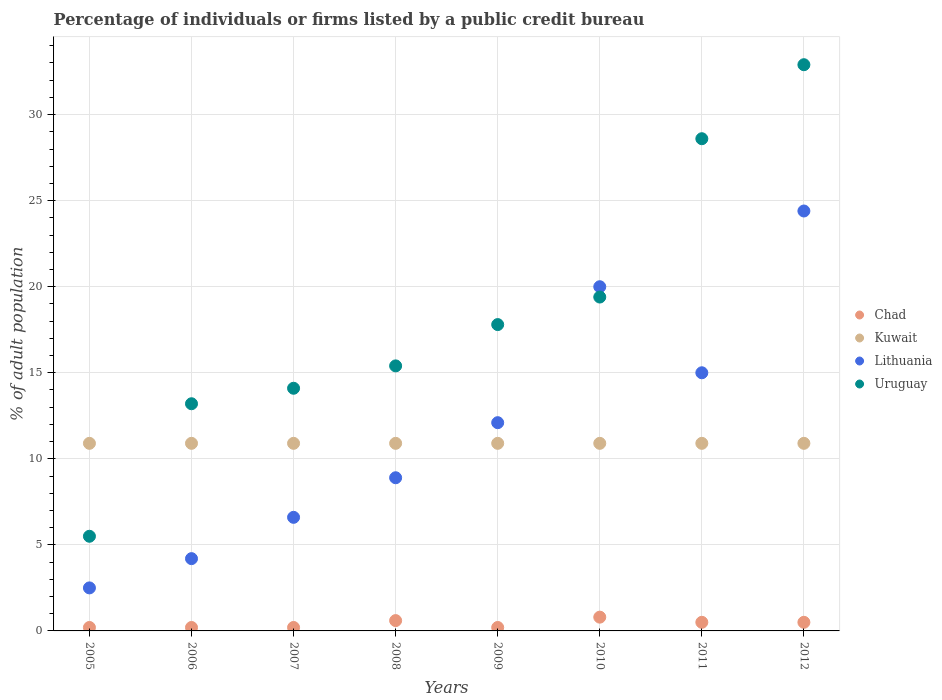How many different coloured dotlines are there?
Keep it short and to the point. 4. Is the number of dotlines equal to the number of legend labels?
Provide a succinct answer. Yes. What is the percentage of population listed by a public credit bureau in Chad in 2011?
Your answer should be compact. 0.5. Across all years, what is the maximum percentage of population listed by a public credit bureau in Kuwait?
Offer a very short reply. 10.9. Across all years, what is the minimum percentage of population listed by a public credit bureau in Lithuania?
Your response must be concise. 2.5. In which year was the percentage of population listed by a public credit bureau in Uruguay maximum?
Keep it short and to the point. 2012. What is the difference between the percentage of population listed by a public credit bureau in Kuwait in 2011 and the percentage of population listed by a public credit bureau in Uruguay in 2008?
Keep it short and to the point. -4.5. What is the average percentage of population listed by a public credit bureau in Chad per year?
Make the answer very short. 0.4. In the year 2007, what is the difference between the percentage of population listed by a public credit bureau in Kuwait and percentage of population listed by a public credit bureau in Lithuania?
Offer a very short reply. 4.3. What is the ratio of the percentage of population listed by a public credit bureau in Uruguay in 2006 to that in 2012?
Offer a terse response. 0.4. What is the difference between the highest and the lowest percentage of population listed by a public credit bureau in Kuwait?
Your answer should be very brief. 0. In how many years, is the percentage of population listed by a public credit bureau in Chad greater than the average percentage of population listed by a public credit bureau in Chad taken over all years?
Offer a terse response. 4. Is it the case that in every year, the sum of the percentage of population listed by a public credit bureau in Uruguay and percentage of population listed by a public credit bureau in Chad  is greater than the percentage of population listed by a public credit bureau in Kuwait?
Your response must be concise. No. Does the percentage of population listed by a public credit bureau in Lithuania monotonically increase over the years?
Your answer should be compact. No. Is the percentage of population listed by a public credit bureau in Kuwait strictly greater than the percentage of population listed by a public credit bureau in Uruguay over the years?
Offer a terse response. No. How many dotlines are there?
Your response must be concise. 4. How many years are there in the graph?
Ensure brevity in your answer.  8. What is the difference between two consecutive major ticks on the Y-axis?
Keep it short and to the point. 5. Are the values on the major ticks of Y-axis written in scientific E-notation?
Your answer should be compact. No. Does the graph contain any zero values?
Offer a terse response. No. What is the title of the graph?
Give a very brief answer. Percentage of individuals or firms listed by a public credit bureau. What is the label or title of the X-axis?
Make the answer very short. Years. What is the label or title of the Y-axis?
Offer a terse response. % of adult population. What is the % of adult population in Chad in 2005?
Ensure brevity in your answer.  0.2. What is the % of adult population of Kuwait in 2005?
Offer a terse response. 10.9. What is the % of adult population in Uruguay in 2005?
Your answer should be very brief. 5.5. What is the % of adult population in Lithuania in 2006?
Offer a terse response. 4.2. What is the % of adult population of Uruguay in 2006?
Offer a terse response. 13.2. What is the % of adult population in Lithuania in 2007?
Keep it short and to the point. 6.6. What is the % of adult population of Uruguay in 2007?
Offer a terse response. 14.1. What is the % of adult population in Chad in 2008?
Your response must be concise. 0.6. What is the % of adult population in Lithuania in 2008?
Make the answer very short. 8.9. What is the % of adult population in Chad in 2009?
Provide a short and direct response. 0.2. What is the % of adult population of Kuwait in 2009?
Offer a very short reply. 10.9. What is the % of adult population of Chad in 2010?
Your response must be concise. 0.8. What is the % of adult population in Lithuania in 2010?
Keep it short and to the point. 20. What is the % of adult population in Chad in 2011?
Your response must be concise. 0.5. What is the % of adult population of Lithuania in 2011?
Keep it short and to the point. 15. What is the % of adult population of Uruguay in 2011?
Your response must be concise. 28.6. What is the % of adult population in Kuwait in 2012?
Provide a short and direct response. 10.9. What is the % of adult population of Lithuania in 2012?
Provide a succinct answer. 24.4. What is the % of adult population in Uruguay in 2012?
Your response must be concise. 32.9. Across all years, what is the maximum % of adult population in Chad?
Keep it short and to the point. 0.8. Across all years, what is the maximum % of adult population of Lithuania?
Your answer should be compact. 24.4. Across all years, what is the maximum % of adult population of Uruguay?
Your response must be concise. 32.9. Across all years, what is the minimum % of adult population of Chad?
Give a very brief answer. 0.2. Across all years, what is the minimum % of adult population in Kuwait?
Provide a succinct answer. 10.9. Across all years, what is the minimum % of adult population in Uruguay?
Your response must be concise. 5.5. What is the total % of adult population in Chad in the graph?
Give a very brief answer. 3.2. What is the total % of adult population of Kuwait in the graph?
Keep it short and to the point. 87.2. What is the total % of adult population in Lithuania in the graph?
Provide a succinct answer. 93.7. What is the total % of adult population in Uruguay in the graph?
Provide a succinct answer. 146.9. What is the difference between the % of adult population of Lithuania in 2005 and that in 2006?
Your response must be concise. -1.7. What is the difference between the % of adult population of Uruguay in 2005 and that in 2006?
Ensure brevity in your answer.  -7.7. What is the difference between the % of adult population of Chad in 2005 and that in 2007?
Your response must be concise. 0. What is the difference between the % of adult population in Lithuania in 2005 and that in 2007?
Your answer should be compact. -4.1. What is the difference between the % of adult population of Uruguay in 2005 and that in 2007?
Offer a terse response. -8.6. What is the difference between the % of adult population of Lithuania in 2005 and that in 2009?
Provide a succinct answer. -9.6. What is the difference between the % of adult population of Chad in 2005 and that in 2010?
Provide a succinct answer. -0.6. What is the difference between the % of adult population in Lithuania in 2005 and that in 2010?
Ensure brevity in your answer.  -17.5. What is the difference between the % of adult population in Uruguay in 2005 and that in 2010?
Offer a terse response. -13.9. What is the difference between the % of adult population of Chad in 2005 and that in 2011?
Provide a short and direct response. -0.3. What is the difference between the % of adult population of Lithuania in 2005 and that in 2011?
Provide a short and direct response. -12.5. What is the difference between the % of adult population in Uruguay in 2005 and that in 2011?
Your answer should be compact. -23.1. What is the difference between the % of adult population in Chad in 2005 and that in 2012?
Your response must be concise. -0.3. What is the difference between the % of adult population of Lithuania in 2005 and that in 2012?
Your answer should be very brief. -21.9. What is the difference between the % of adult population of Uruguay in 2005 and that in 2012?
Offer a very short reply. -27.4. What is the difference between the % of adult population in Lithuania in 2006 and that in 2007?
Make the answer very short. -2.4. What is the difference between the % of adult population of Lithuania in 2006 and that in 2008?
Your answer should be compact. -4.7. What is the difference between the % of adult population in Chad in 2006 and that in 2009?
Ensure brevity in your answer.  0. What is the difference between the % of adult population in Lithuania in 2006 and that in 2009?
Offer a terse response. -7.9. What is the difference between the % of adult population in Uruguay in 2006 and that in 2009?
Ensure brevity in your answer.  -4.6. What is the difference between the % of adult population in Chad in 2006 and that in 2010?
Your answer should be very brief. -0.6. What is the difference between the % of adult population in Lithuania in 2006 and that in 2010?
Offer a terse response. -15.8. What is the difference between the % of adult population of Kuwait in 2006 and that in 2011?
Offer a terse response. 0. What is the difference between the % of adult population of Uruguay in 2006 and that in 2011?
Provide a succinct answer. -15.4. What is the difference between the % of adult population in Chad in 2006 and that in 2012?
Ensure brevity in your answer.  -0.3. What is the difference between the % of adult population of Kuwait in 2006 and that in 2012?
Your response must be concise. 0. What is the difference between the % of adult population of Lithuania in 2006 and that in 2012?
Ensure brevity in your answer.  -20.2. What is the difference between the % of adult population in Uruguay in 2006 and that in 2012?
Provide a succinct answer. -19.7. What is the difference between the % of adult population of Kuwait in 2007 and that in 2008?
Offer a terse response. 0. What is the difference between the % of adult population of Chad in 2007 and that in 2009?
Give a very brief answer. 0. What is the difference between the % of adult population of Chad in 2007 and that in 2010?
Your answer should be compact. -0.6. What is the difference between the % of adult population of Kuwait in 2007 and that in 2010?
Make the answer very short. 0. What is the difference between the % of adult population of Uruguay in 2007 and that in 2010?
Keep it short and to the point. -5.3. What is the difference between the % of adult population of Uruguay in 2007 and that in 2011?
Offer a very short reply. -14.5. What is the difference between the % of adult population in Chad in 2007 and that in 2012?
Your answer should be compact. -0.3. What is the difference between the % of adult population in Kuwait in 2007 and that in 2012?
Provide a succinct answer. 0. What is the difference between the % of adult population of Lithuania in 2007 and that in 2012?
Keep it short and to the point. -17.8. What is the difference between the % of adult population in Uruguay in 2007 and that in 2012?
Your answer should be very brief. -18.8. What is the difference between the % of adult population of Lithuania in 2008 and that in 2009?
Give a very brief answer. -3.2. What is the difference between the % of adult population of Uruguay in 2008 and that in 2009?
Offer a terse response. -2.4. What is the difference between the % of adult population in Chad in 2008 and that in 2010?
Provide a succinct answer. -0.2. What is the difference between the % of adult population in Lithuania in 2008 and that in 2010?
Offer a very short reply. -11.1. What is the difference between the % of adult population in Uruguay in 2008 and that in 2010?
Make the answer very short. -4. What is the difference between the % of adult population in Chad in 2008 and that in 2011?
Your answer should be very brief. 0.1. What is the difference between the % of adult population of Lithuania in 2008 and that in 2011?
Your answer should be compact. -6.1. What is the difference between the % of adult population in Kuwait in 2008 and that in 2012?
Ensure brevity in your answer.  0. What is the difference between the % of adult population in Lithuania in 2008 and that in 2012?
Make the answer very short. -15.5. What is the difference between the % of adult population of Uruguay in 2008 and that in 2012?
Provide a succinct answer. -17.5. What is the difference between the % of adult population in Chad in 2009 and that in 2010?
Your answer should be very brief. -0.6. What is the difference between the % of adult population in Chad in 2009 and that in 2011?
Ensure brevity in your answer.  -0.3. What is the difference between the % of adult population of Kuwait in 2009 and that in 2011?
Offer a terse response. 0. What is the difference between the % of adult population of Uruguay in 2009 and that in 2011?
Your response must be concise. -10.8. What is the difference between the % of adult population in Chad in 2009 and that in 2012?
Ensure brevity in your answer.  -0.3. What is the difference between the % of adult population of Uruguay in 2009 and that in 2012?
Provide a succinct answer. -15.1. What is the difference between the % of adult population of Kuwait in 2010 and that in 2011?
Your answer should be very brief. 0. What is the difference between the % of adult population of Lithuania in 2010 and that in 2012?
Your answer should be compact. -4.4. What is the difference between the % of adult population in Chad in 2011 and that in 2012?
Your answer should be compact. 0. What is the difference between the % of adult population in Uruguay in 2011 and that in 2012?
Your response must be concise. -4.3. What is the difference between the % of adult population in Chad in 2005 and the % of adult population in Lithuania in 2006?
Keep it short and to the point. -4. What is the difference between the % of adult population in Chad in 2005 and the % of adult population in Uruguay in 2006?
Keep it short and to the point. -13. What is the difference between the % of adult population of Kuwait in 2005 and the % of adult population of Lithuania in 2006?
Provide a succinct answer. 6.7. What is the difference between the % of adult population in Chad in 2005 and the % of adult population in Kuwait in 2007?
Offer a very short reply. -10.7. What is the difference between the % of adult population in Chad in 2005 and the % of adult population in Uruguay in 2007?
Ensure brevity in your answer.  -13.9. What is the difference between the % of adult population of Kuwait in 2005 and the % of adult population of Lithuania in 2007?
Your response must be concise. 4.3. What is the difference between the % of adult population in Lithuania in 2005 and the % of adult population in Uruguay in 2007?
Offer a very short reply. -11.6. What is the difference between the % of adult population in Chad in 2005 and the % of adult population in Kuwait in 2008?
Ensure brevity in your answer.  -10.7. What is the difference between the % of adult population in Chad in 2005 and the % of adult population in Lithuania in 2008?
Your response must be concise. -8.7. What is the difference between the % of adult population in Chad in 2005 and the % of adult population in Uruguay in 2008?
Keep it short and to the point. -15.2. What is the difference between the % of adult population in Kuwait in 2005 and the % of adult population in Lithuania in 2008?
Offer a very short reply. 2. What is the difference between the % of adult population in Chad in 2005 and the % of adult population in Kuwait in 2009?
Your response must be concise. -10.7. What is the difference between the % of adult population in Chad in 2005 and the % of adult population in Uruguay in 2009?
Make the answer very short. -17.6. What is the difference between the % of adult population of Kuwait in 2005 and the % of adult population of Lithuania in 2009?
Ensure brevity in your answer.  -1.2. What is the difference between the % of adult population of Kuwait in 2005 and the % of adult population of Uruguay in 2009?
Your answer should be very brief. -6.9. What is the difference between the % of adult population in Lithuania in 2005 and the % of adult population in Uruguay in 2009?
Keep it short and to the point. -15.3. What is the difference between the % of adult population in Chad in 2005 and the % of adult population in Kuwait in 2010?
Your answer should be compact. -10.7. What is the difference between the % of adult population in Chad in 2005 and the % of adult population in Lithuania in 2010?
Provide a short and direct response. -19.8. What is the difference between the % of adult population in Chad in 2005 and the % of adult population in Uruguay in 2010?
Keep it short and to the point. -19.2. What is the difference between the % of adult population in Kuwait in 2005 and the % of adult population in Uruguay in 2010?
Make the answer very short. -8.5. What is the difference between the % of adult population of Lithuania in 2005 and the % of adult population of Uruguay in 2010?
Your answer should be very brief. -16.9. What is the difference between the % of adult population of Chad in 2005 and the % of adult population of Kuwait in 2011?
Offer a terse response. -10.7. What is the difference between the % of adult population in Chad in 2005 and the % of adult population in Lithuania in 2011?
Keep it short and to the point. -14.8. What is the difference between the % of adult population in Chad in 2005 and the % of adult population in Uruguay in 2011?
Your answer should be compact. -28.4. What is the difference between the % of adult population of Kuwait in 2005 and the % of adult population of Lithuania in 2011?
Ensure brevity in your answer.  -4.1. What is the difference between the % of adult population of Kuwait in 2005 and the % of adult population of Uruguay in 2011?
Your answer should be compact. -17.7. What is the difference between the % of adult population of Lithuania in 2005 and the % of adult population of Uruguay in 2011?
Your response must be concise. -26.1. What is the difference between the % of adult population in Chad in 2005 and the % of adult population in Lithuania in 2012?
Your answer should be very brief. -24.2. What is the difference between the % of adult population in Chad in 2005 and the % of adult population in Uruguay in 2012?
Keep it short and to the point. -32.7. What is the difference between the % of adult population of Lithuania in 2005 and the % of adult population of Uruguay in 2012?
Give a very brief answer. -30.4. What is the difference between the % of adult population in Chad in 2006 and the % of adult population in Lithuania in 2007?
Your response must be concise. -6.4. What is the difference between the % of adult population of Chad in 2006 and the % of adult population of Uruguay in 2007?
Offer a terse response. -13.9. What is the difference between the % of adult population in Kuwait in 2006 and the % of adult population in Uruguay in 2007?
Make the answer very short. -3.2. What is the difference between the % of adult population of Lithuania in 2006 and the % of adult population of Uruguay in 2007?
Offer a very short reply. -9.9. What is the difference between the % of adult population in Chad in 2006 and the % of adult population in Kuwait in 2008?
Give a very brief answer. -10.7. What is the difference between the % of adult population of Chad in 2006 and the % of adult population of Uruguay in 2008?
Provide a short and direct response. -15.2. What is the difference between the % of adult population of Kuwait in 2006 and the % of adult population of Lithuania in 2008?
Provide a succinct answer. 2. What is the difference between the % of adult population in Chad in 2006 and the % of adult population in Lithuania in 2009?
Provide a short and direct response. -11.9. What is the difference between the % of adult population in Chad in 2006 and the % of adult population in Uruguay in 2009?
Make the answer very short. -17.6. What is the difference between the % of adult population in Lithuania in 2006 and the % of adult population in Uruguay in 2009?
Your response must be concise. -13.6. What is the difference between the % of adult population of Chad in 2006 and the % of adult population of Kuwait in 2010?
Your answer should be compact. -10.7. What is the difference between the % of adult population of Chad in 2006 and the % of adult population of Lithuania in 2010?
Make the answer very short. -19.8. What is the difference between the % of adult population of Chad in 2006 and the % of adult population of Uruguay in 2010?
Ensure brevity in your answer.  -19.2. What is the difference between the % of adult population in Lithuania in 2006 and the % of adult population in Uruguay in 2010?
Ensure brevity in your answer.  -15.2. What is the difference between the % of adult population of Chad in 2006 and the % of adult population of Lithuania in 2011?
Offer a very short reply. -14.8. What is the difference between the % of adult population in Chad in 2006 and the % of adult population in Uruguay in 2011?
Offer a terse response. -28.4. What is the difference between the % of adult population of Kuwait in 2006 and the % of adult population of Uruguay in 2011?
Provide a short and direct response. -17.7. What is the difference between the % of adult population in Lithuania in 2006 and the % of adult population in Uruguay in 2011?
Give a very brief answer. -24.4. What is the difference between the % of adult population in Chad in 2006 and the % of adult population in Lithuania in 2012?
Offer a very short reply. -24.2. What is the difference between the % of adult population of Chad in 2006 and the % of adult population of Uruguay in 2012?
Your response must be concise. -32.7. What is the difference between the % of adult population of Kuwait in 2006 and the % of adult population of Lithuania in 2012?
Ensure brevity in your answer.  -13.5. What is the difference between the % of adult population in Kuwait in 2006 and the % of adult population in Uruguay in 2012?
Your answer should be compact. -22. What is the difference between the % of adult population of Lithuania in 2006 and the % of adult population of Uruguay in 2012?
Provide a succinct answer. -28.7. What is the difference between the % of adult population of Chad in 2007 and the % of adult population of Kuwait in 2008?
Your answer should be very brief. -10.7. What is the difference between the % of adult population of Chad in 2007 and the % of adult population of Uruguay in 2008?
Your response must be concise. -15.2. What is the difference between the % of adult population of Lithuania in 2007 and the % of adult population of Uruguay in 2008?
Provide a succinct answer. -8.8. What is the difference between the % of adult population in Chad in 2007 and the % of adult population in Kuwait in 2009?
Provide a short and direct response. -10.7. What is the difference between the % of adult population in Chad in 2007 and the % of adult population in Lithuania in 2009?
Your response must be concise. -11.9. What is the difference between the % of adult population of Chad in 2007 and the % of adult population of Uruguay in 2009?
Your answer should be very brief. -17.6. What is the difference between the % of adult population of Kuwait in 2007 and the % of adult population of Lithuania in 2009?
Give a very brief answer. -1.2. What is the difference between the % of adult population in Kuwait in 2007 and the % of adult population in Uruguay in 2009?
Your answer should be compact. -6.9. What is the difference between the % of adult population in Lithuania in 2007 and the % of adult population in Uruguay in 2009?
Offer a terse response. -11.2. What is the difference between the % of adult population of Chad in 2007 and the % of adult population of Lithuania in 2010?
Your answer should be compact. -19.8. What is the difference between the % of adult population of Chad in 2007 and the % of adult population of Uruguay in 2010?
Give a very brief answer. -19.2. What is the difference between the % of adult population of Kuwait in 2007 and the % of adult population of Lithuania in 2010?
Provide a succinct answer. -9.1. What is the difference between the % of adult population in Chad in 2007 and the % of adult population in Lithuania in 2011?
Keep it short and to the point. -14.8. What is the difference between the % of adult population of Chad in 2007 and the % of adult population of Uruguay in 2011?
Offer a very short reply. -28.4. What is the difference between the % of adult population in Kuwait in 2007 and the % of adult population in Uruguay in 2011?
Offer a very short reply. -17.7. What is the difference between the % of adult population in Chad in 2007 and the % of adult population in Lithuania in 2012?
Offer a terse response. -24.2. What is the difference between the % of adult population in Chad in 2007 and the % of adult population in Uruguay in 2012?
Offer a very short reply. -32.7. What is the difference between the % of adult population of Kuwait in 2007 and the % of adult population of Uruguay in 2012?
Your response must be concise. -22. What is the difference between the % of adult population of Lithuania in 2007 and the % of adult population of Uruguay in 2012?
Ensure brevity in your answer.  -26.3. What is the difference between the % of adult population in Chad in 2008 and the % of adult population in Kuwait in 2009?
Your response must be concise. -10.3. What is the difference between the % of adult population in Chad in 2008 and the % of adult population in Uruguay in 2009?
Offer a terse response. -17.2. What is the difference between the % of adult population of Kuwait in 2008 and the % of adult population of Uruguay in 2009?
Provide a short and direct response. -6.9. What is the difference between the % of adult population in Lithuania in 2008 and the % of adult population in Uruguay in 2009?
Offer a very short reply. -8.9. What is the difference between the % of adult population of Chad in 2008 and the % of adult population of Kuwait in 2010?
Provide a succinct answer. -10.3. What is the difference between the % of adult population of Chad in 2008 and the % of adult population of Lithuania in 2010?
Provide a succinct answer. -19.4. What is the difference between the % of adult population in Chad in 2008 and the % of adult population in Uruguay in 2010?
Make the answer very short. -18.8. What is the difference between the % of adult population of Kuwait in 2008 and the % of adult population of Lithuania in 2010?
Ensure brevity in your answer.  -9.1. What is the difference between the % of adult population in Kuwait in 2008 and the % of adult population in Uruguay in 2010?
Give a very brief answer. -8.5. What is the difference between the % of adult population in Lithuania in 2008 and the % of adult population in Uruguay in 2010?
Provide a short and direct response. -10.5. What is the difference between the % of adult population of Chad in 2008 and the % of adult population of Kuwait in 2011?
Provide a short and direct response. -10.3. What is the difference between the % of adult population in Chad in 2008 and the % of adult population in Lithuania in 2011?
Keep it short and to the point. -14.4. What is the difference between the % of adult population of Chad in 2008 and the % of adult population of Uruguay in 2011?
Offer a terse response. -28. What is the difference between the % of adult population of Kuwait in 2008 and the % of adult population of Uruguay in 2011?
Make the answer very short. -17.7. What is the difference between the % of adult population in Lithuania in 2008 and the % of adult population in Uruguay in 2011?
Offer a terse response. -19.7. What is the difference between the % of adult population of Chad in 2008 and the % of adult population of Lithuania in 2012?
Offer a very short reply. -23.8. What is the difference between the % of adult population of Chad in 2008 and the % of adult population of Uruguay in 2012?
Keep it short and to the point. -32.3. What is the difference between the % of adult population in Kuwait in 2008 and the % of adult population in Lithuania in 2012?
Provide a succinct answer. -13.5. What is the difference between the % of adult population of Lithuania in 2008 and the % of adult population of Uruguay in 2012?
Offer a terse response. -24. What is the difference between the % of adult population in Chad in 2009 and the % of adult population in Lithuania in 2010?
Provide a succinct answer. -19.8. What is the difference between the % of adult population of Chad in 2009 and the % of adult population of Uruguay in 2010?
Make the answer very short. -19.2. What is the difference between the % of adult population of Kuwait in 2009 and the % of adult population of Uruguay in 2010?
Offer a terse response. -8.5. What is the difference between the % of adult population of Chad in 2009 and the % of adult population of Lithuania in 2011?
Offer a very short reply. -14.8. What is the difference between the % of adult population of Chad in 2009 and the % of adult population of Uruguay in 2011?
Give a very brief answer. -28.4. What is the difference between the % of adult population in Kuwait in 2009 and the % of adult population in Uruguay in 2011?
Your answer should be compact. -17.7. What is the difference between the % of adult population in Lithuania in 2009 and the % of adult population in Uruguay in 2011?
Your response must be concise. -16.5. What is the difference between the % of adult population of Chad in 2009 and the % of adult population of Kuwait in 2012?
Keep it short and to the point. -10.7. What is the difference between the % of adult population in Chad in 2009 and the % of adult population in Lithuania in 2012?
Your answer should be compact. -24.2. What is the difference between the % of adult population of Chad in 2009 and the % of adult population of Uruguay in 2012?
Your response must be concise. -32.7. What is the difference between the % of adult population in Kuwait in 2009 and the % of adult population in Lithuania in 2012?
Your answer should be very brief. -13.5. What is the difference between the % of adult population in Kuwait in 2009 and the % of adult population in Uruguay in 2012?
Offer a very short reply. -22. What is the difference between the % of adult population in Lithuania in 2009 and the % of adult population in Uruguay in 2012?
Provide a short and direct response. -20.8. What is the difference between the % of adult population in Chad in 2010 and the % of adult population in Kuwait in 2011?
Give a very brief answer. -10.1. What is the difference between the % of adult population of Chad in 2010 and the % of adult population of Lithuania in 2011?
Your answer should be compact. -14.2. What is the difference between the % of adult population of Chad in 2010 and the % of adult population of Uruguay in 2011?
Offer a terse response. -27.8. What is the difference between the % of adult population in Kuwait in 2010 and the % of adult population in Uruguay in 2011?
Make the answer very short. -17.7. What is the difference between the % of adult population of Lithuania in 2010 and the % of adult population of Uruguay in 2011?
Give a very brief answer. -8.6. What is the difference between the % of adult population of Chad in 2010 and the % of adult population of Kuwait in 2012?
Your answer should be compact. -10.1. What is the difference between the % of adult population of Chad in 2010 and the % of adult population of Lithuania in 2012?
Provide a succinct answer. -23.6. What is the difference between the % of adult population in Chad in 2010 and the % of adult population in Uruguay in 2012?
Keep it short and to the point. -32.1. What is the difference between the % of adult population in Kuwait in 2010 and the % of adult population in Uruguay in 2012?
Provide a short and direct response. -22. What is the difference between the % of adult population in Chad in 2011 and the % of adult population in Kuwait in 2012?
Your answer should be compact. -10.4. What is the difference between the % of adult population of Chad in 2011 and the % of adult population of Lithuania in 2012?
Your answer should be compact. -23.9. What is the difference between the % of adult population of Chad in 2011 and the % of adult population of Uruguay in 2012?
Keep it short and to the point. -32.4. What is the difference between the % of adult population in Lithuania in 2011 and the % of adult population in Uruguay in 2012?
Offer a very short reply. -17.9. What is the average % of adult population in Kuwait per year?
Provide a short and direct response. 10.9. What is the average % of adult population in Lithuania per year?
Keep it short and to the point. 11.71. What is the average % of adult population in Uruguay per year?
Offer a very short reply. 18.36. In the year 2005, what is the difference between the % of adult population in Kuwait and % of adult population in Lithuania?
Your response must be concise. 8.4. In the year 2005, what is the difference between the % of adult population of Kuwait and % of adult population of Uruguay?
Ensure brevity in your answer.  5.4. In the year 2006, what is the difference between the % of adult population in Chad and % of adult population in Kuwait?
Ensure brevity in your answer.  -10.7. In the year 2006, what is the difference between the % of adult population of Chad and % of adult population of Lithuania?
Your answer should be compact. -4. In the year 2006, what is the difference between the % of adult population of Kuwait and % of adult population of Lithuania?
Offer a terse response. 6.7. In the year 2006, what is the difference between the % of adult population in Kuwait and % of adult population in Uruguay?
Your answer should be very brief. -2.3. In the year 2006, what is the difference between the % of adult population of Lithuania and % of adult population of Uruguay?
Ensure brevity in your answer.  -9. In the year 2007, what is the difference between the % of adult population in Kuwait and % of adult population in Lithuania?
Provide a succinct answer. 4.3. In the year 2007, what is the difference between the % of adult population of Lithuania and % of adult population of Uruguay?
Your answer should be compact. -7.5. In the year 2008, what is the difference between the % of adult population in Chad and % of adult population in Uruguay?
Ensure brevity in your answer.  -14.8. In the year 2008, what is the difference between the % of adult population in Lithuania and % of adult population in Uruguay?
Provide a succinct answer. -6.5. In the year 2009, what is the difference between the % of adult population of Chad and % of adult population of Kuwait?
Your answer should be very brief. -10.7. In the year 2009, what is the difference between the % of adult population of Chad and % of adult population of Uruguay?
Keep it short and to the point. -17.6. In the year 2009, what is the difference between the % of adult population of Lithuania and % of adult population of Uruguay?
Provide a short and direct response. -5.7. In the year 2010, what is the difference between the % of adult population of Chad and % of adult population of Lithuania?
Your response must be concise. -19.2. In the year 2010, what is the difference between the % of adult population of Chad and % of adult population of Uruguay?
Keep it short and to the point. -18.6. In the year 2010, what is the difference between the % of adult population in Kuwait and % of adult population in Lithuania?
Your response must be concise. -9.1. In the year 2010, what is the difference between the % of adult population in Kuwait and % of adult population in Uruguay?
Keep it short and to the point. -8.5. In the year 2011, what is the difference between the % of adult population in Chad and % of adult population in Lithuania?
Give a very brief answer. -14.5. In the year 2011, what is the difference between the % of adult population in Chad and % of adult population in Uruguay?
Keep it short and to the point. -28.1. In the year 2011, what is the difference between the % of adult population in Kuwait and % of adult population in Lithuania?
Give a very brief answer. -4.1. In the year 2011, what is the difference between the % of adult population in Kuwait and % of adult population in Uruguay?
Your answer should be compact. -17.7. In the year 2011, what is the difference between the % of adult population of Lithuania and % of adult population of Uruguay?
Provide a succinct answer. -13.6. In the year 2012, what is the difference between the % of adult population of Chad and % of adult population of Kuwait?
Offer a terse response. -10.4. In the year 2012, what is the difference between the % of adult population of Chad and % of adult population of Lithuania?
Your response must be concise. -23.9. In the year 2012, what is the difference between the % of adult population in Chad and % of adult population in Uruguay?
Ensure brevity in your answer.  -32.4. In the year 2012, what is the difference between the % of adult population of Lithuania and % of adult population of Uruguay?
Your answer should be very brief. -8.5. What is the ratio of the % of adult population of Chad in 2005 to that in 2006?
Give a very brief answer. 1. What is the ratio of the % of adult population in Lithuania in 2005 to that in 2006?
Offer a terse response. 0.6. What is the ratio of the % of adult population in Uruguay in 2005 to that in 2006?
Your answer should be very brief. 0.42. What is the ratio of the % of adult population in Kuwait in 2005 to that in 2007?
Your answer should be compact. 1. What is the ratio of the % of adult population of Lithuania in 2005 to that in 2007?
Your answer should be compact. 0.38. What is the ratio of the % of adult population of Uruguay in 2005 to that in 2007?
Your answer should be very brief. 0.39. What is the ratio of the % of adult population in Chad in 2005 to that in 2008?
Give a very brief answer. 0.33. What is the ratio of the % of adult population in Lithuania in 2005 to that in 2008?
Offer a terse response. 0.28. What is the ratio of the % of adult population of Uruguay in 2005 to that in 2008?
Offer a terse response. 0.36. What is the ratio of the % of adult population in Lithuania in 2005 to that in 2009?
Offer a terse response. 0.21. What is the ratio of the % of adult population of Uruguay in 2005 to that in 2009?
Ensure brevity in your answer.  0.31. What is the ratio of the % of adult population in Chad in 2005 to that in 2010?
Your answer should be compact. 0.25. What is the ratio of the % of adult population in Lithuania in 2005 to that in 2010?
Your answer should be compact. 0.12. What is the ratio of the % of adult population in Uruguay in 2005 to that in 2010?
Your answer should be compact. 0.28. What is the ratio of the % of adult population in Kuwait in 2005 to that in 2011?
Give a very brief answer. 1. What is the ratio of the % of adult population of Uruguay in 2005 to that in 2011?
Give a very brief answer. 0.19. What is the ratio of the % of adult population in Chad in 2005 to that in 2012?
Give a very brief answer. 0.4. What is the ratio of the % of adult population in Lithuania in 2005 to that in 2012?
Provide a short and direct response. 0.1. What is the ratio of the % of adult population in Uruguay in 2005 to that in 2012?
Your response must be concise. 0.17. What is the ratio of the % of adult population in Kuwait in 2006 to that in 2007?
Provide a short and direct response. 1. What is the ratio of the % of adult population of Lithuania in 2006 to that in 2007?
Provide a short and direct response. 0.64. What is the ratio of the % of adult population of Uruguay in 2006 to that in 2007?
Offer a very short reply. 0.94. What is the ratio of the % of adult population of Lithuania in 2006 to that in 2008?
Your answer should be very brief. 0.47. What is the ratio of the % of adult population in Chad in 2006 to that in 2009?
Provide a succinct answer. 1. What is the ratio of the % of adult population in Lithuania in 2006 to that in 2009?
Ensure brevity in your answer.  0.35. What is the ratio of the % of adult population in Uruguay in 2006 to that in 2009?
Your response must be concise. 0.74. What is the ratio of the % of adult population in Chad in 2006 to that in 2010?
Provide a short and direct response. 0.25. What is the ratio of the % of adult population in Lithuania in 2006 to that in 2010?
Your answer should be very brief. 0.21. What is the ratio of the % of adult population in Uruguay in 2006 to that in 2010?
Provide a succinct answer. 0.68. What is the ratio of the % of adult population in Kuwait in 2006 to that in 2011?
Provide a succinct answer. 1. What is the ratio of the % of adult population in Lithuania in 2006 to that in 2011?
Offer a terse response. 0.28. What is the ratio of the % of adult population of Uruguay in 2006 to that in 2011?
Offer a very short reply. 0.46. What is the ratio of the % of adult population of Chad in 2006 to that in 2012?
Provide a succinct answer. 0.4. What is the ratio of the % of adult population of Lithuania in 2006 to that in 2012?
Your answer should be very brief. 0.17. What is the ratio of the % of adult population of Uruguay in 2006 to that in 2012?
Your answer should be very brief. 0.4. What is the ratio of the % of adult population in Lithuania in 2007 to that in 2008?
Your response must be concise. 0.74. What is the ratio of the % of adult population in Uruguay in 2007 to that in 2008?
Offer a very short reply. 0.92. What is the ratio of the % of adult population in Lithuania in 2007 to that in 2009?
Provide a succinct answer. 0.55. What is the ratio of the % of adult population of Uruguay in 2007 to that in 2009?
Your response must be concise. 0.79. What is the ratio of the % of adult population in Chad in 2007 to that in 2010?
Provide a succinct answer. 0.25. What is the ratio of the % of adult population of Kuwait in 2007 to that in 2010?
Keep it short and to the point. 1. What is the ratio of the % of adult population in Lithuania in 2007 to that in 2010?
Keep it short and to the point. 0.33. What is the ratio of the % of adult population in Uruguay in 2007 to that in 2010?
Give a very brief answer. 0.73. What is the ratio of the % of adult population in Lithuania in 2007 to that in 2011?
Your answer should be compact. 0.44. What is the ratio of the % of adult population in Uruguay in 2007 to that in 2011?
Provide a succinct answer. 0.49. What is the ratio of the % of adult population in Chad in 2007 to that in 2012?
Your answer should be compact. 0.4. What is the ratio of the % of adult population in Lithuania in 2007 to that in 2012?
Provide a succinct answer. 0.27. What is the ratio of the % of adult population of Uruguay in 2007 to that in 2012?
Make the answer very short. 0.43. What is the ratio of the % of adult population of Lithuania in 2008 to that in 2009?
Your answer should be very brief. 0.74. What is the ratio of the % of adult population of Uruguay in 2008 to that in 2009?
Make the answer very short. 0.87. What is the ratio of the % of adult population in Lithuania in 2008 to that in 2010?
Offer a very short reply. 0.45. What is the ratio of the % of adult population of Uruguay in 2008 to that in 2010?
Provide a short and direct response. 0.79. What is the ratio of the % of adult population in Lithuania in 2008 to that in 2011?
Keep it short and to the point. 0.59. What is the ratio of the % of adult population in Uruguay in 2008 to that in 2011?
Provide a succinct answer. 0.54. What is the ratio of the % of adult population in Lithuania in 2008 to that in 2012?
Your response must be concise. 0.36. What is the ratio of the % of adult population in Uruguay in 2008 to that in 2012?
Provide a succinct answer. 0.47. What is the ratio of the % of adult population of Chad in 2009 to that in 2010?
Offer a terse response. 0.25. What is the ratio of the % of adult population in Kuwait in 2009 to that in 2010?
Ensure brevity in your answer.  1. What is the ratio of the % of adult population in Lithuania in 2009 to that in 2010?
Provide a succinct answer. 0.6. What is the ratio of the % of adult population of Uruguay in 2009 to that in 2010?
Make the answer very short. 0.92. What is the ratio of the % of adult population of Chad in 2009 to that in 2011?
Your answer should be compact. 0.4. What is the ratio of the % of adult population of Kuwait in 2009 to that in 2011?
Your answer should be very brief. 1. What is the ratio of the % of adult population of Lithuania in 2009 to that in 2011?
Ensure brevity in your answer.  0.81. What is the ratio of the % of adult population in Uruguay in 2009 to that in 2011?
Your answer should be compact. 0.62. What is the ratio of the % of adult population in Chad in 2009 to that in 2012?
Your response must be concise. 0.4. What is the ratio of the % of adult population of Lithuania in 2009 to that in 2012?
Make the answer very short. 0.5. What is the ratio of the % of adult population in Uruguay in 2009 to that in 2012?
Your answer should be very brief. 0.54. What is the ratio of the % of adult population in Chad in 2010 to that in 2011?
Make the answer very short. 1.6. What is the ratio of the % of adult population of Uruguay in 2010 to that in 2011?
Provide a short and direct response. 0.68. What is the ratio of the % of adult population of Kuwait in 2010 to that in 2012?
Make the answer very short. 1. What is the ratio of the % of adult population in Lithuania in 2010 to that in 2012?
Your answer should be compact. 0.82. What is the ratio of the % of adult population of Uruguay in 2010 to that in 2012?
Your answer should be compact. 0.59. What is the ratio of the % of adult population in Kuwait in 2011 to that in 2012?
Keep it short and to the point. 1. What is the ratio of the % of adult population of Lithuania in 2011 to that in 2012?
Ensure brevity in your answer.  0.61. What is the ratio of the % of adult population in Uruguay in 2011 to that in 2012?
Give a very brief answer. 0.87. What is the difference between the highest and the second highest % of adult population in Chad?
Ensure brevity in your answer.  0.2. What is the difference between the highest and the second highest % of adult population of Kuwait?
Your answer should be very brief. 0. What is the difference between the highest and the second highest % of adult population of Lithuania?
Make the answer very short. 4.4. What is the difference between the highest and the second highest % of adult population of Uruguay?
Make the answer very short. 4.3. What is the difference between the highest and the lowest % of adult population in Lithuania?
Your answer should be compact. 21.9. What is the difference between the highest and the lowest % of adult population of Uruguay?
Your answer should be very brief. 27.4. 